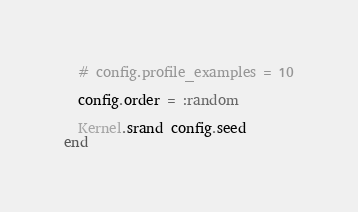<code> <loc_0><loc_0><loc_500><loc_500><_Ruby_>
  # config.profile_examples = 10

  config.order = :random

  Kernel.srand config.seed
end
</code> 